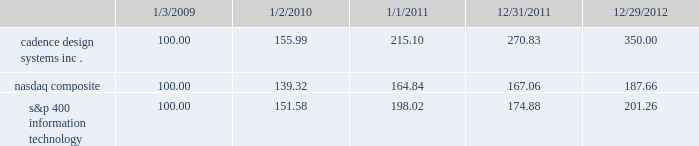The following graph compares the cumulative 4-year total stockholder return on our common stock relative to the cumulative total return of the nasdaq composite index and the s&p 400 information technology index .
The graph assumes that the value of the investment in our common stock and in each index ( including reinvestment of dividends ) was $ 100 on january 3 , 2009 and tracks it through december 29 , 2012 .
Comparison of 4 year cumulative total return* among cadence design systems , inc. , the nasdaq composite index , and s&p 400 information technology cadence design systems , inc .
Nasdaq composite s&p 400 information technology 12/29/121/1/11 12/31/111/2/101/3/09 *$ 100 invested on 1/3/09 in stock or 12/31/08 in index , including reinvestment of dividends .
Indexes calculated on month-end basis .
Copyright a9 2013 s&p , a division of the mcgraw-hill companies all rights reserved. .
The stock price performance included in this graph is not necessarily indicative of future stock price performance. .
What is the total return if $ 1000000 are invested in nasdaq composite in 2009 and sold in 2010? 
Computations: (1000000 * ((139.32 - 100) / 100))
Answer: 393200.0. 